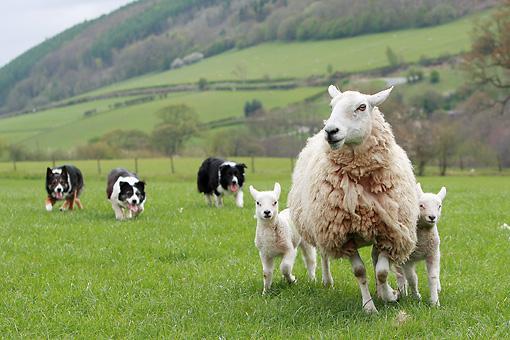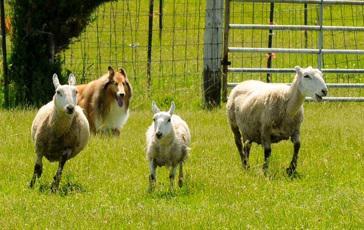The first image is the image on the left, the second image is the image on the right. Assess this claim about the two images: "At least one image shows a dog at the right herding no more than three sheep, which are at the left.". Correct or not? Answer yes or no. No. 